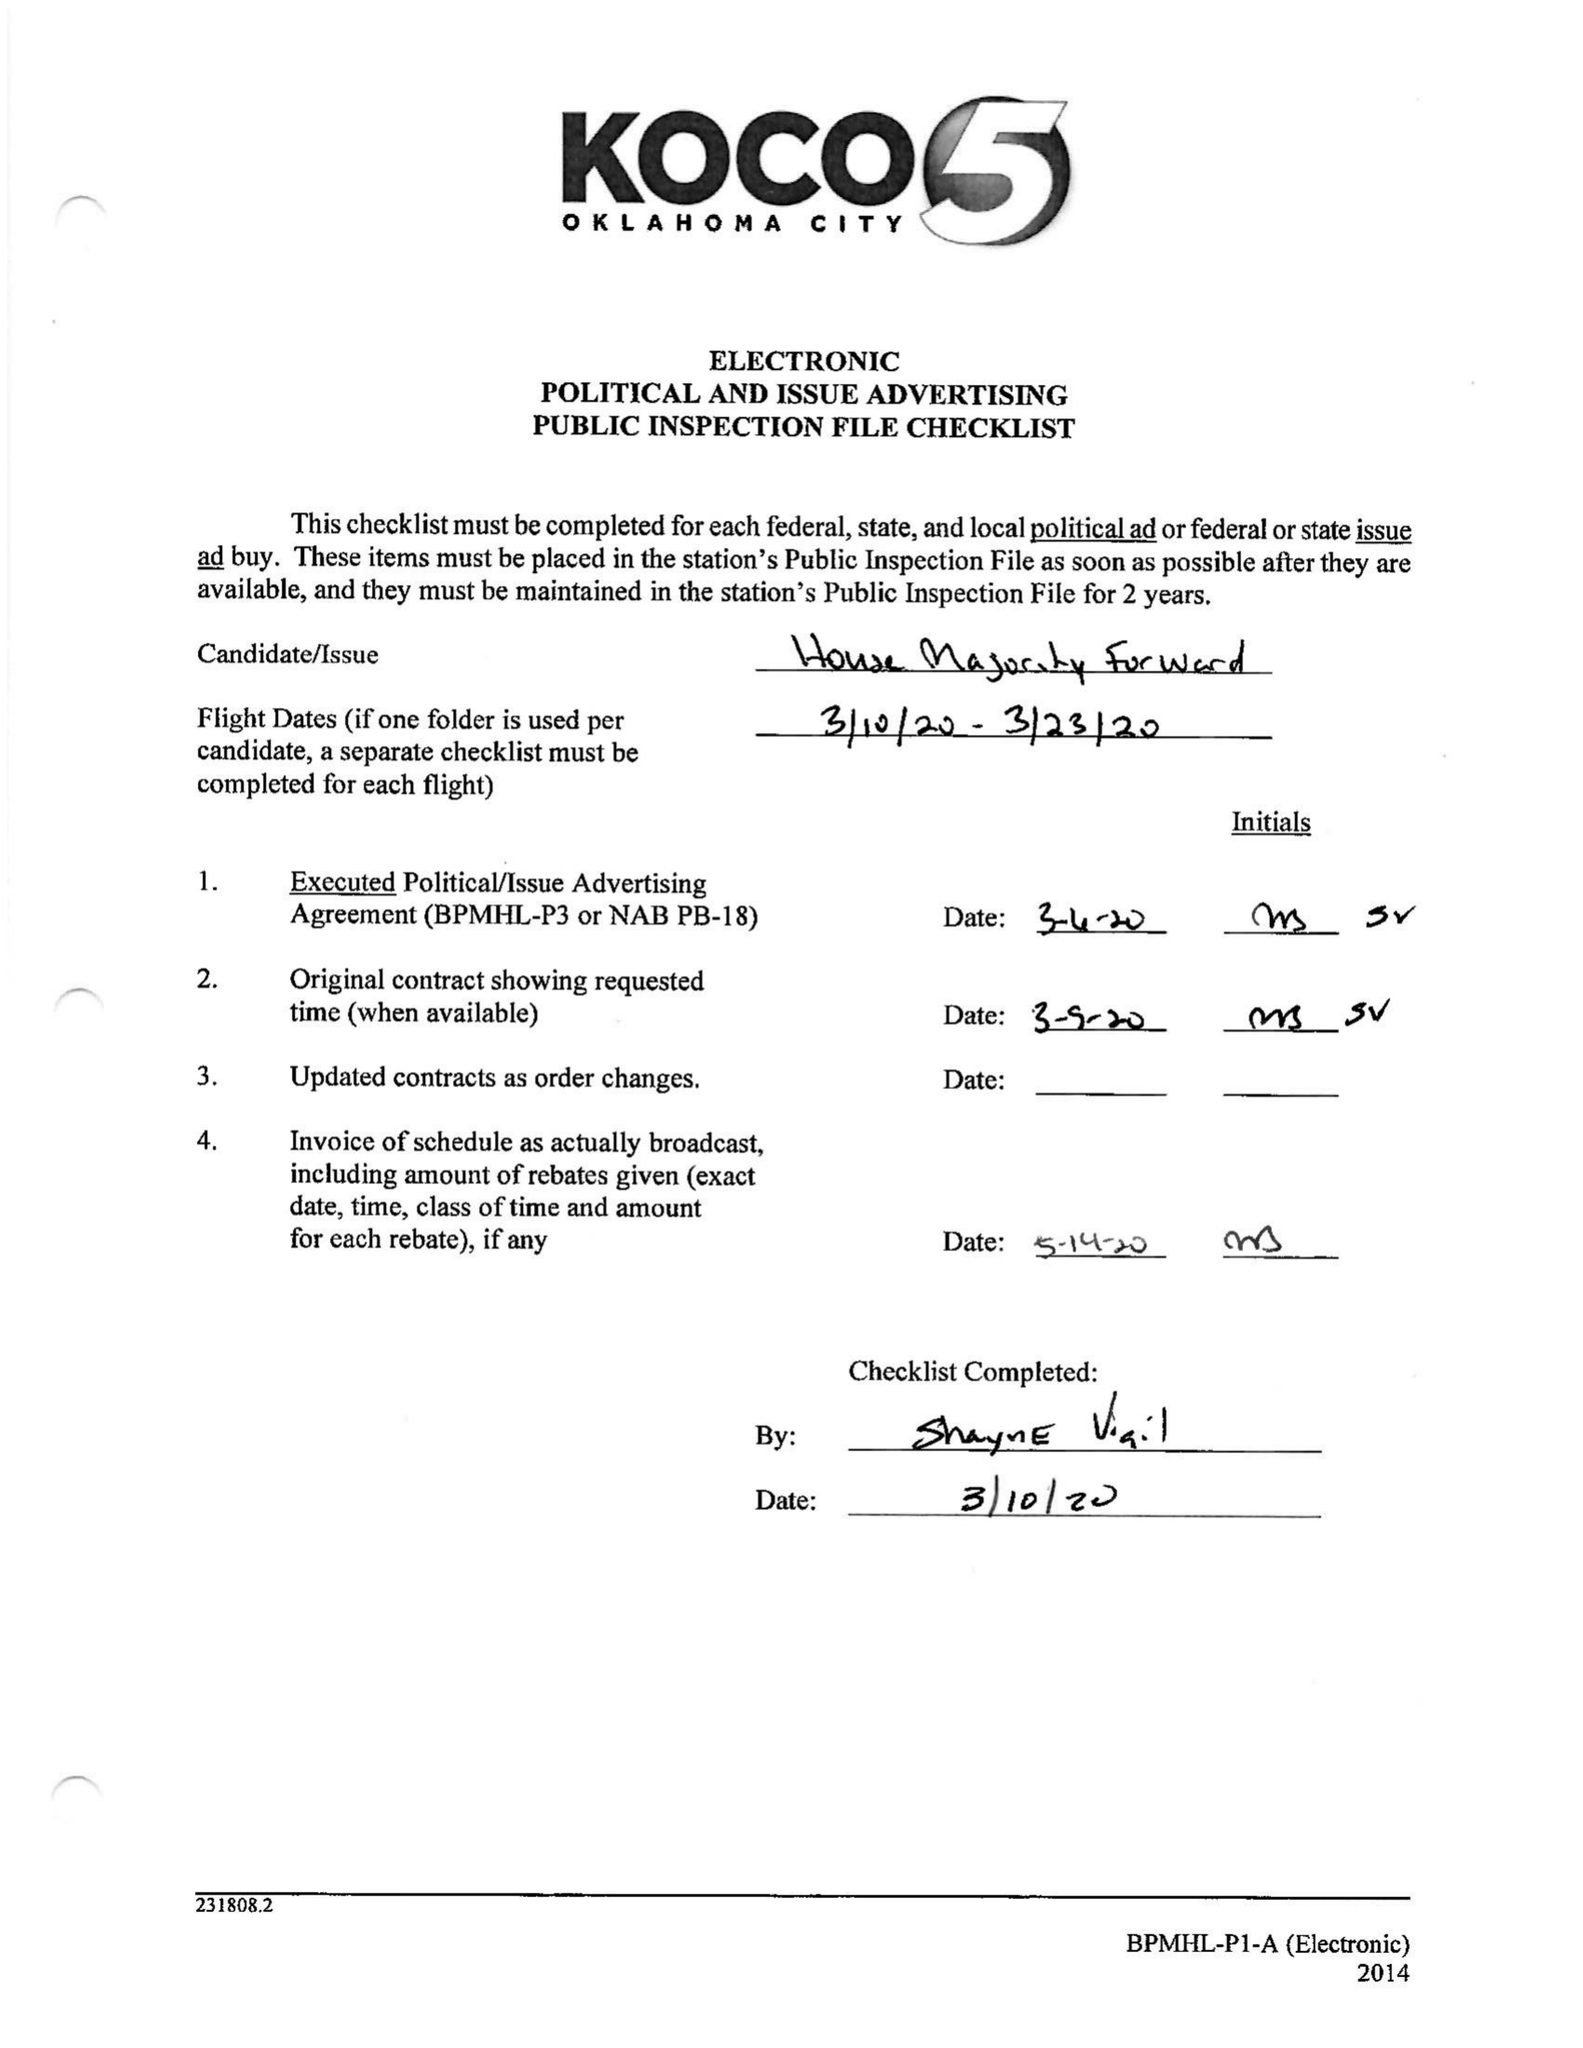What is the value for the flight_from?
Answer the question using a single word or phrase. 03/10/20 